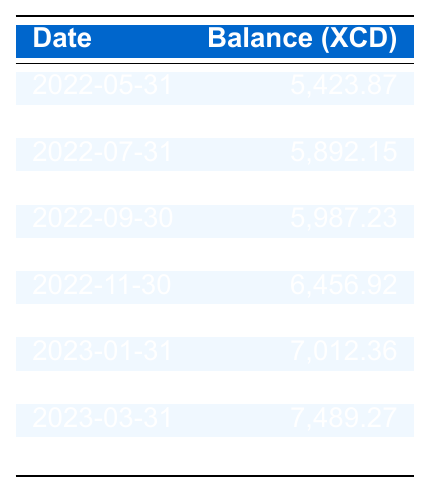What was the balance on May 31, 2022? The table shows the balance for each date. The entry for May 31, 2022, indicates a balance of 5,423.87.
Answer: 5,423.87 What is the highest account balance recorded during this period? The table lists all balances, and the largest entry is for April 30, 2023, which shows a balance of 7,732.69.
Answer: 7,732.69 How many times did the account balance exceed 7,000.00? By reviewing the balances, the account exceeded 7,000.00 in the entries for January, February, March, and April 2023, totaling 4 times.
Answer: 4 What is the average balance for the last three months? The last three months are January, February, and March 2023 with balances of 7,012.36, 7,245.81, and 7,489.27. Adding these gives 21,747.44, and dividing by 3 gives an average of 7,249.15.
Answer: 7,249.15 Did the balance change positively from March to April 2023? The balance in March 2023 was 7,489.27 and increased to 7,732.69 in April 2023, indicating a positive change.
Answer: Yes What was the overall change in balance from May 2022 to April 2023? The balance in May 2022 was 5,423.87 and in April 2023, it was 7,732.69. The change is calculated as 7,732.69 - 5,423.87 = 2,308.82.
Answer: 2,308.82 Which month had the lowest balance during this period? The balance entry for May 2022 is the lowest at 5,423.87 compared to other months.
Answer: May 2022 What is the median balance for this year? The data for this year (January to April 2023) shows balances of 7,012.36, 7,245.81, 7,489.27, and 7,732.69. Arranging these in order gives 7,012.36, 7,245.81, 7,489.27, and 7,732.69. The median is the average of the two middle values: (7,245.81 + 7,489.27) / 2 = 7,367.54.
Answer: 7,367.54 How does the balance on December 31, 2022, compare to that of September 30, 2022? The balance on December 31, 2022, was 6,789.54, while on September 30, 2022, it was 5,987.23. The comparison shows an increase of 802.31.
Answer: Increase Were there any months where the balance decreased compared to the previous month? By examining the table, the only decrease occurred from August to September 2022, where the balance dropped from 6,102.45 to 5,987.23.
Answer: Yes 